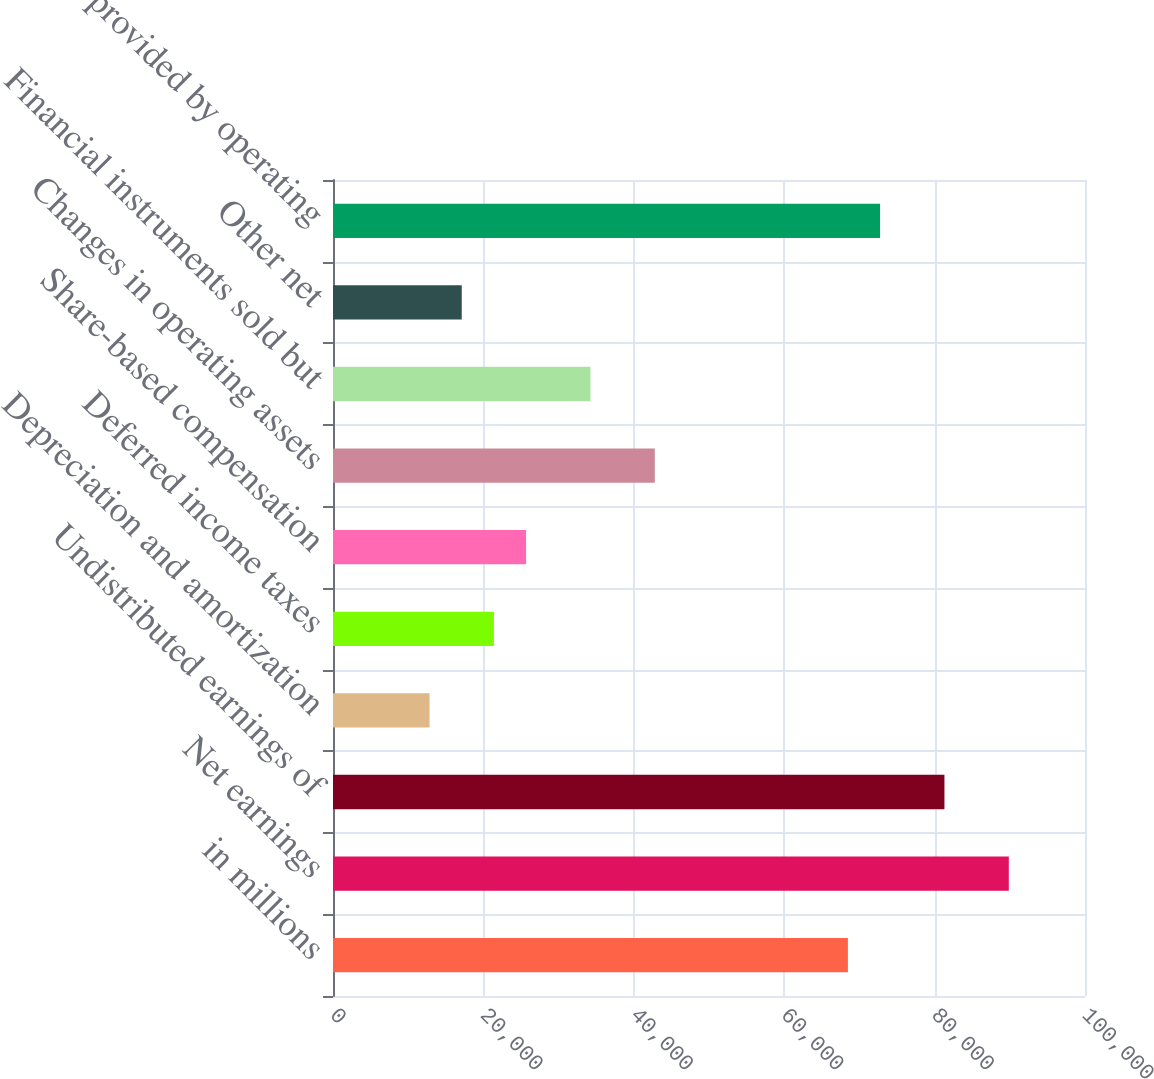Convert chart to OTSL. <chart><loc_0><loc_0><loc_500><loc_500><bar_chart><fcel>in millions<fcel>Net earnings<fcel>Undistributed earnings of<fcel>Depreciation and amortization<fcel>Deferred income taxes<fcel>Share-based compensation<fcel>Changes in operating assets<fcel>Financial instruments sold but<fcel>Other net<fcel>Net cash provided by operating<nl><fcel>68470.8<fcel>89867.3<fcel>81308.7<fcel>12839.9<fcel>21398.5<fcel>25677.8<fcel>42795<fcel>34236.4<fcel>17119.2<fcel>72750.1<nl></chart> 